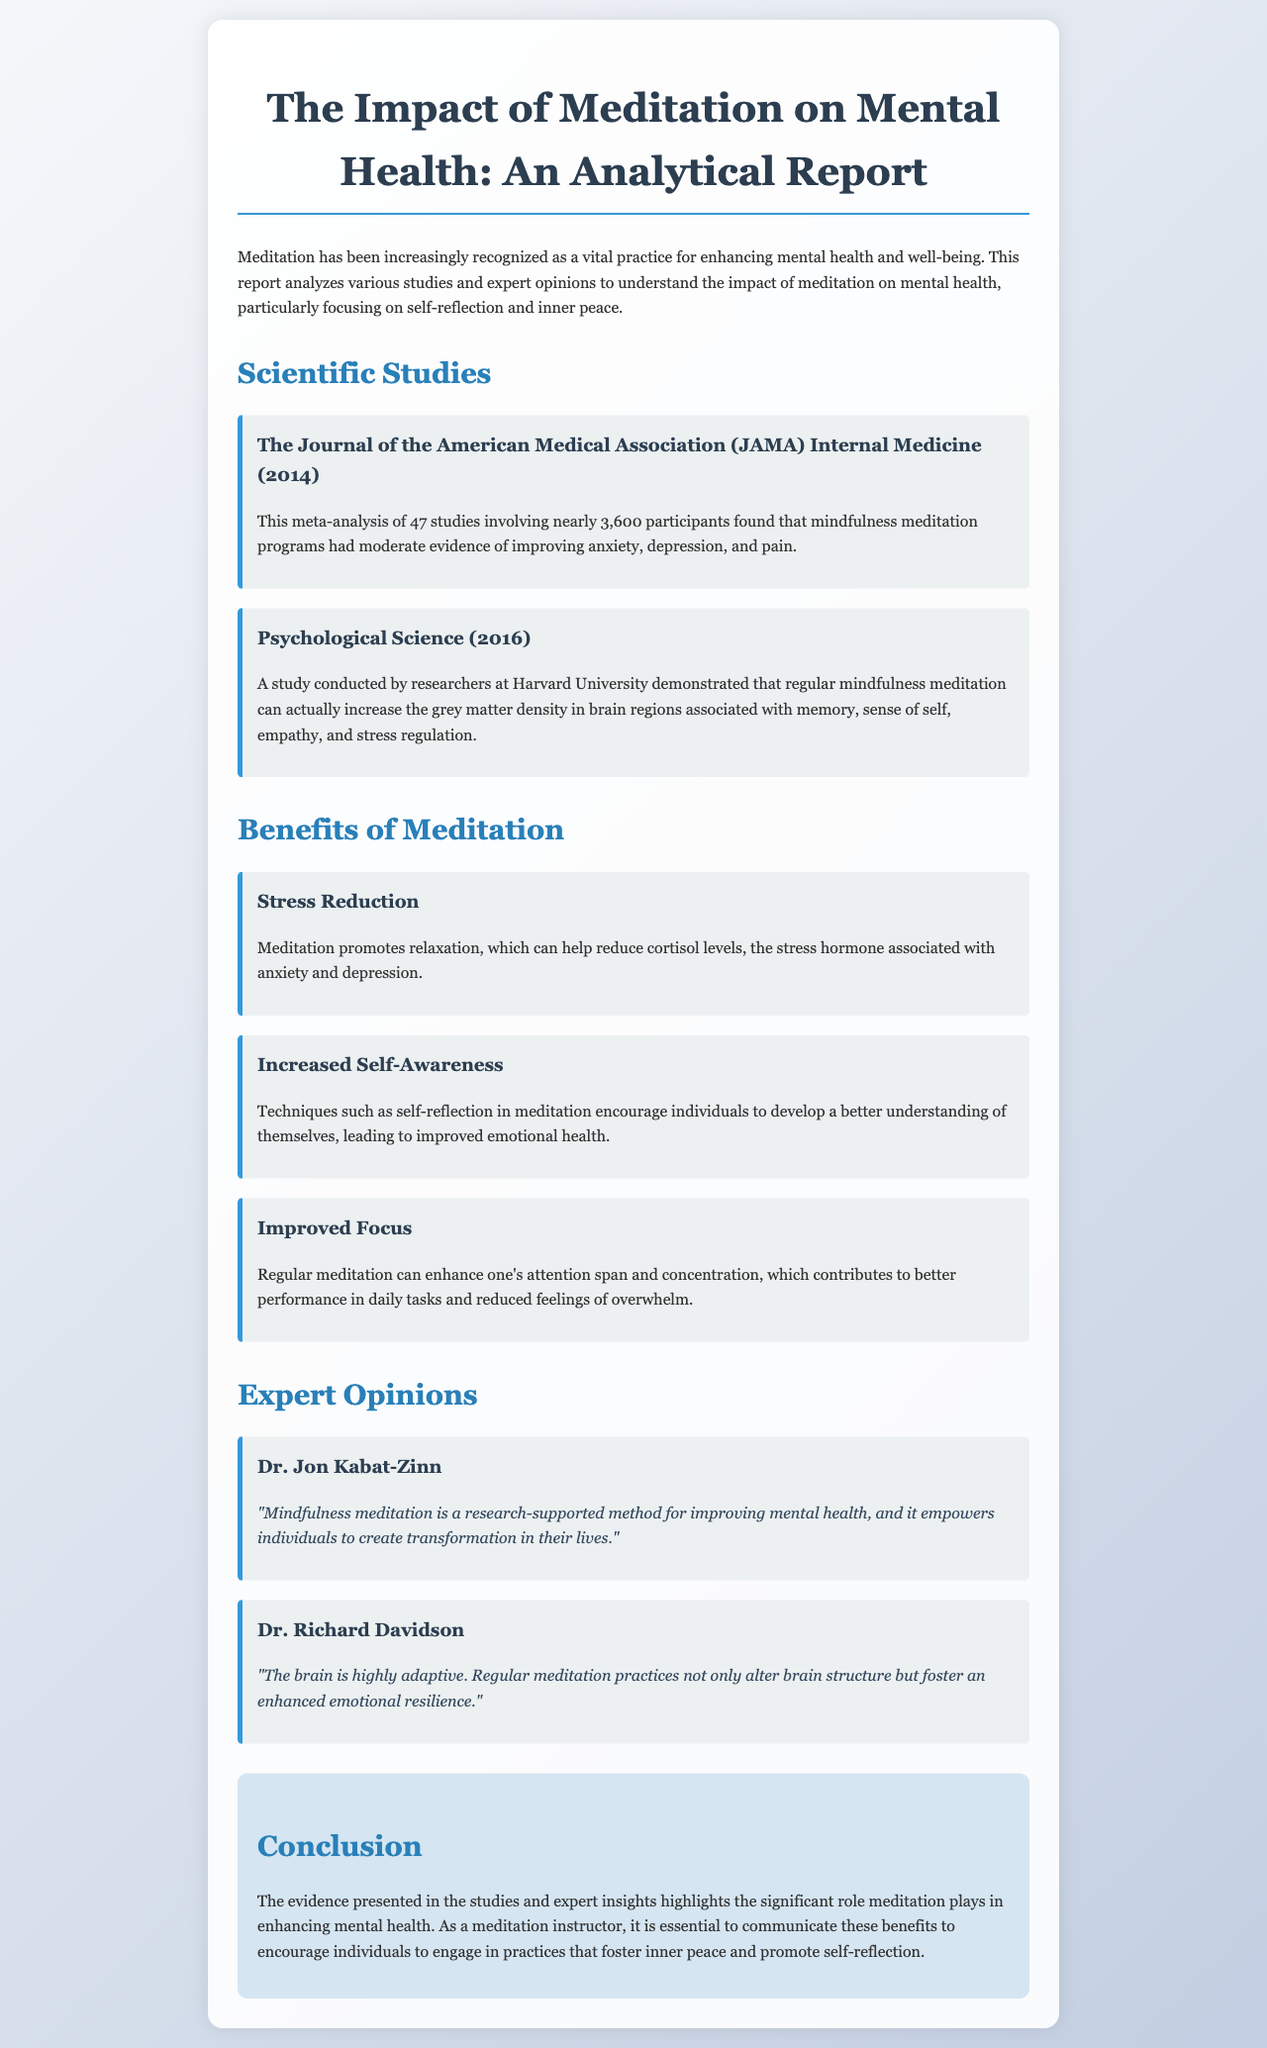What is the title of the report? The title of the report is presented prominently at the beginning of the document.
Answer: The Impact of Meditation on Mental Health: An Analytical Report How many studies were involved in the JAMA meta-analysis? The number of studies mentioned in the JAMA meta-analysis is found in the corresponding section of the document.
Answer: 47 studies Who conducted the study published in Psychological Science in 2016? The name of the institution conducting the study in 2016 is mentioned in the document.
Answer: Harvard University What benefit does meditation provide related to stress? The specific benefit associated with stress reduction is provided in the benefits section of the report.
Answer: Stress Reduction According to Dr. Jon Kabat-Zinn, what does mindfulness meditation empower individuals to do? The quote from Dr. Jon Kabat-Zinn includes a specific outcome of mindfulness meditation.
Answer: Create transformation What is one major change in the brain associated with regular meditation? The type of brain change discussed in the expert opinions section provides insight into the effects of meditation.
Answer: Enhanced emotional resilience What type of meditation is highlighted as beneficial for self-reflection? The specific technique mentioned in the benefits section relates to self-awareness and emotional health.
Answer: Self-reflection What does the conclusion emphasize the importance of? The concluding section summarizes the main message of the report regarding meditation's impact on health.
Answer: Communicating benefits 